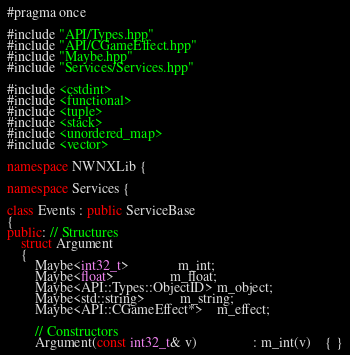<code> <loc_0><loc_0><loc_500><loc_500><_C++_>#pragma once

#include "API/Types.hpp"
#include "API/CGameEffect.hpp"
#include "Maybe.hpp"
#include "Services/Services.hpp"

#include <cstdint>
#include <functional>
#include <tuple>
#include <stack>
#include <unordered_map>
#include <vector>

namespace NWNXLib {

namespace Services {

class Events : public ServiceBase
{
public: // Structures
    struct Argument
    {
        Maybe<int32_t>              m_int;
        Maybe<float>                m_float;
        Maybe<API::Types::ObjectID> m_object;
        Maybe<std::string>          m_string;
        Maybe<API::CGameEffect*>    m_effect;

        // Constructors
        Argument(const int32_t& v)                : m_int(v)    { }</code> 